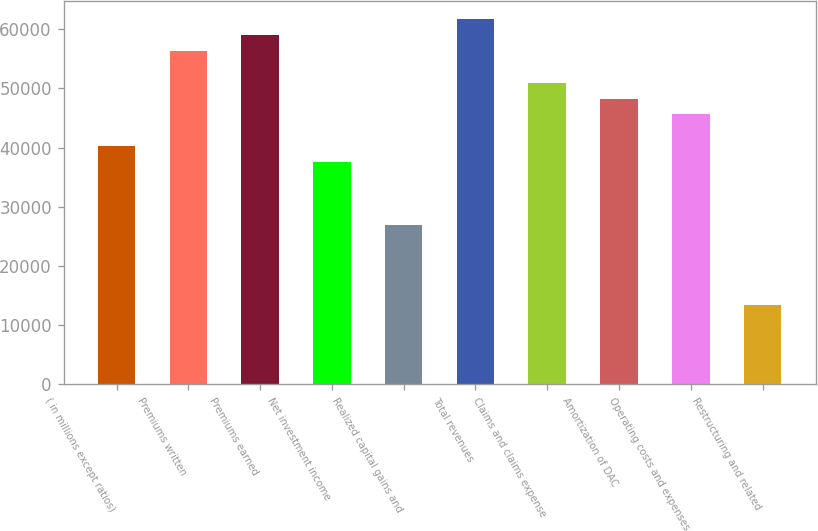Convert chart to OTSL. <chart><loc_0><loc_0><loc_500><loc_500><bar_chart><fcel>( in millions except ratios)<fcel>Premiums written<fcel>Premiums earned<fcel>Net investment income<fcel>Realized capital gains and<fcel>Total revenues<fcel>Claims and claims expense<fcel>Amortization of DAC<fcel>Operating costs and expenses<fcel>Restructuring and related<nl><fcel>40237.4<fcel>56332.4<fcel>59014.9<fcel>37555<fcel>26825<fcel>61697.4<fcel>50967.4<fcel>48284.9<fcel>45602.4<fcel>13412.5<nl></chart> 